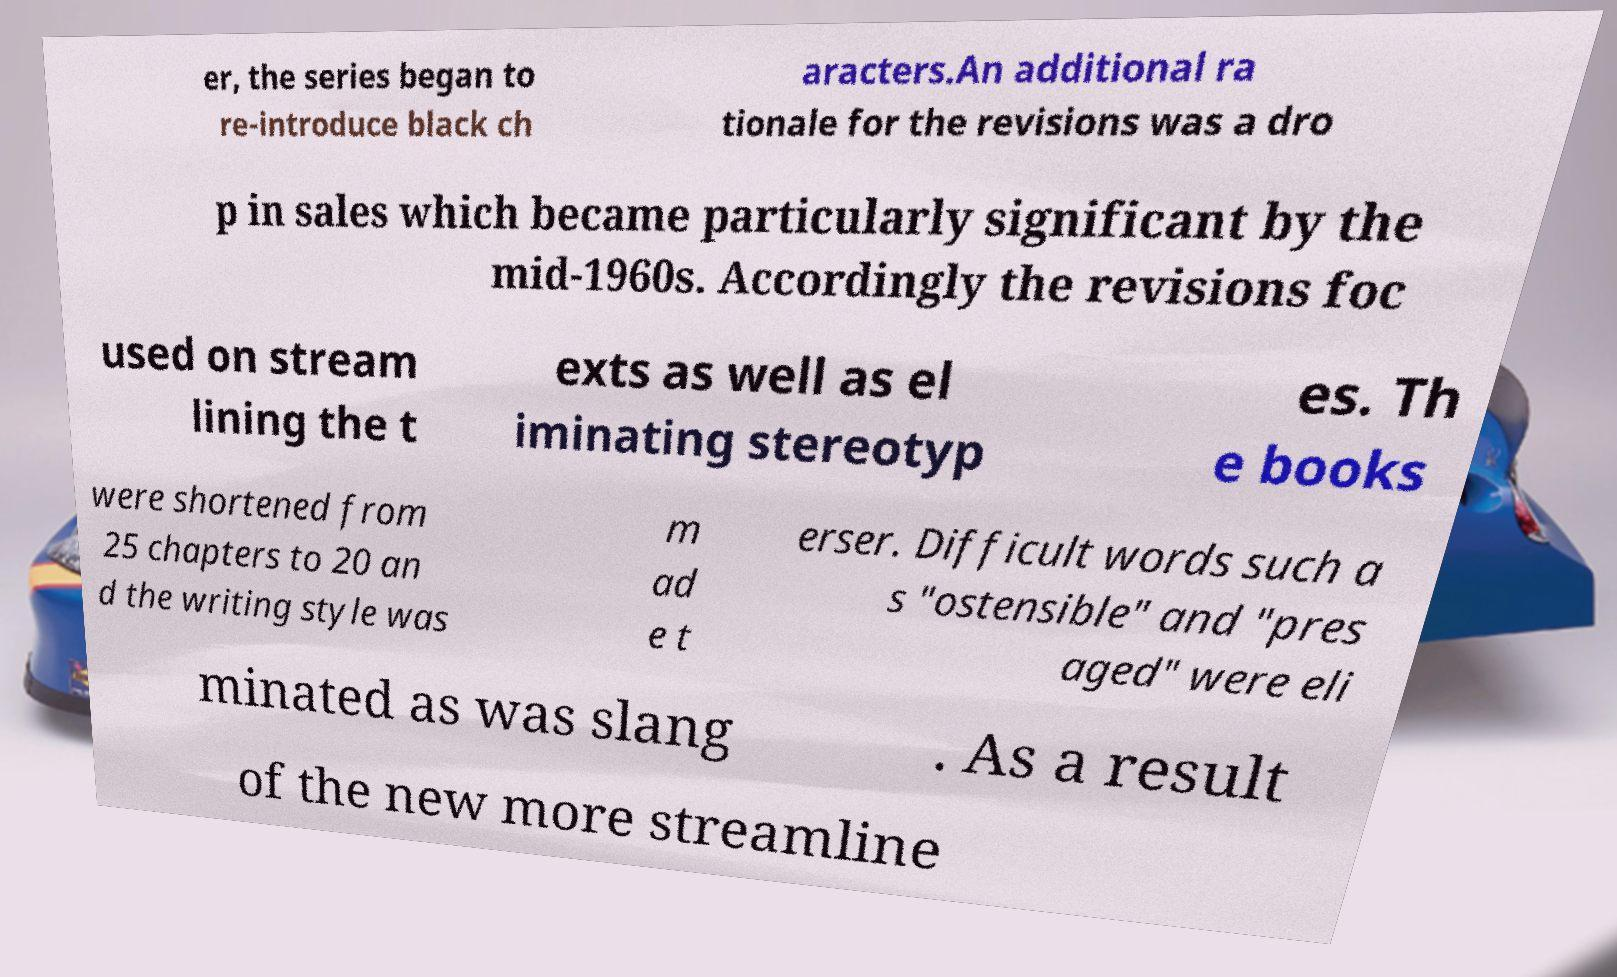Please identify and transcribe the text found in this image. er, the series began to re-introduce black ch aracters.An additional ra tionale for the revisions was a dro p in sales which became particularly significant by the mid-1960s. Accordingly the revisions foc used on stream lining the t exts as well as el iminating stereotyp es. Th e books were shortened from 25 chapters to 20 an d the writing style was m ad e t erser. Difficult words such a s "ostensible" and "pres aged" were eli minated as was slang . As a result of the new more streamline 